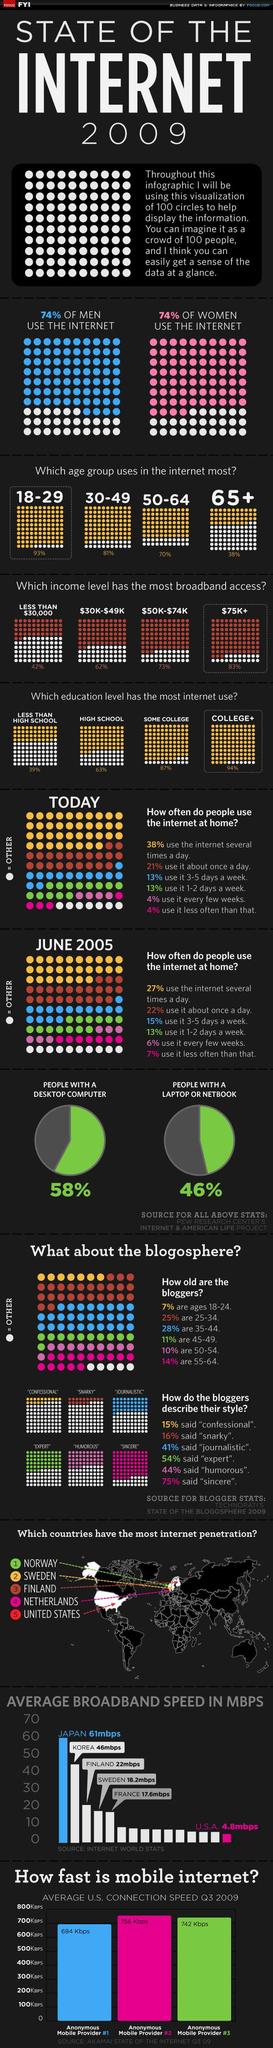Mention a couple of crucial points in this snapshot. The $75K+ income level had the most broadband access. According to recent statistics, a staggering 93% of 18-29 year olds are active internet users. The United States ranks 15th in average broadband speed among countries, according to the latest data. According to a recent survey, a significant percentage of people do not own a desktop computer, with 42% falling into this category. According to the data, the age group that uses the internet the least is 65 years old and above. 